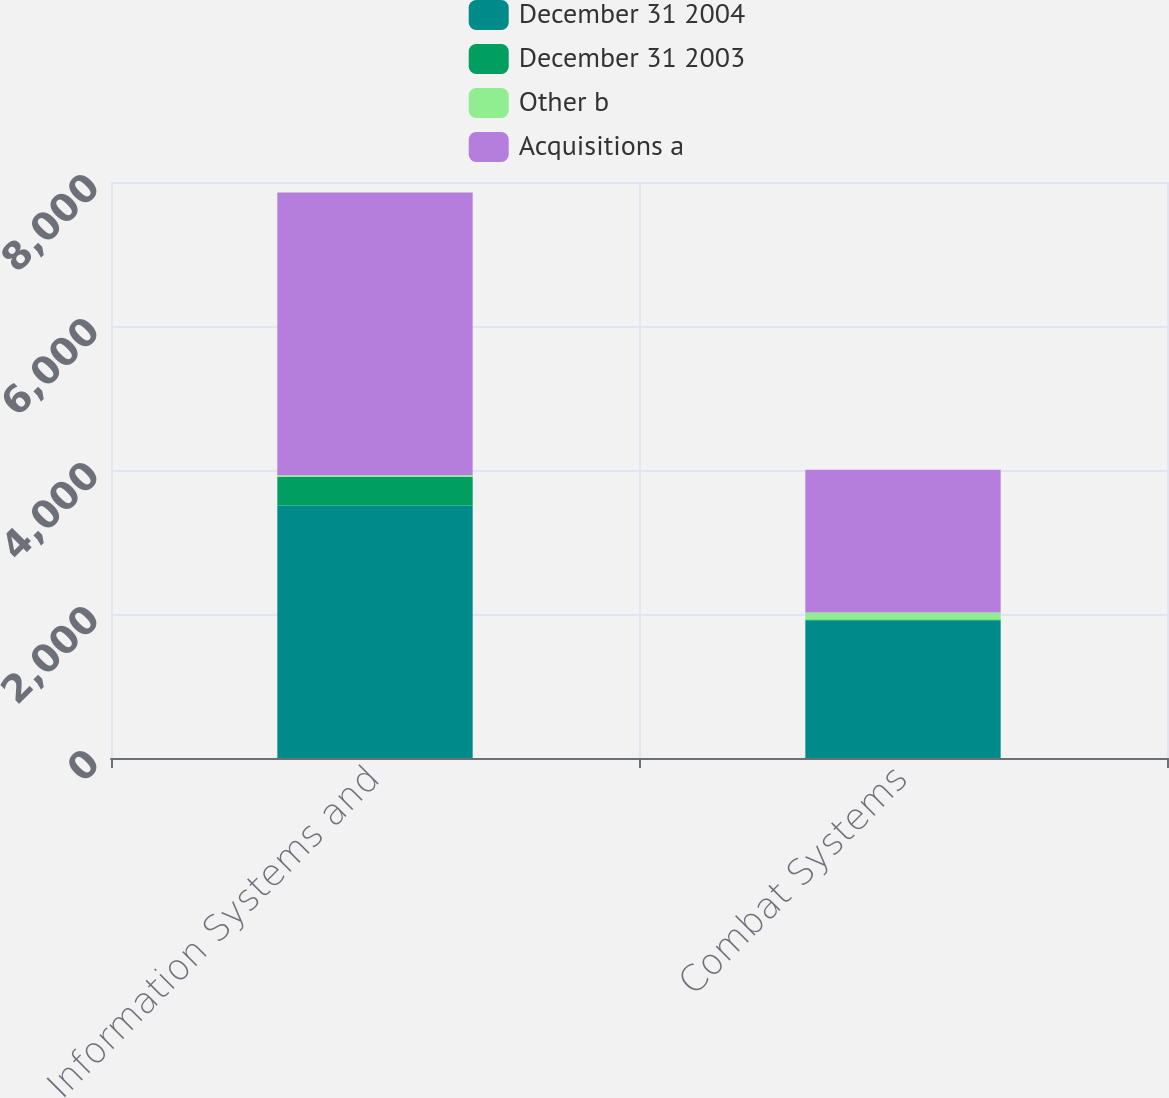Convert chart to OTSL. <chart><loc_0><loc_0><loc_500><loc_500><stacked_bar_chart><ecel><fcel>Information Systems and<fcel>Combat Systems<nl><fcel>December 31 2004<fcel>3508<fcel>1905<nl><fcel>December 31 2003<fcel>397<fcel>20<nl><fcel>Other b<fcel>22<fcel>97<nl><fcel>Acquisitions a<fcel>3927<fcel>1982<nl></chart> 